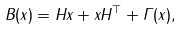<formula> <loc_0><loc_0><loc_500><loc_500>B ( x ) = H x + x H ^ { \top } + \Gamma ( x ) ,</formula> 